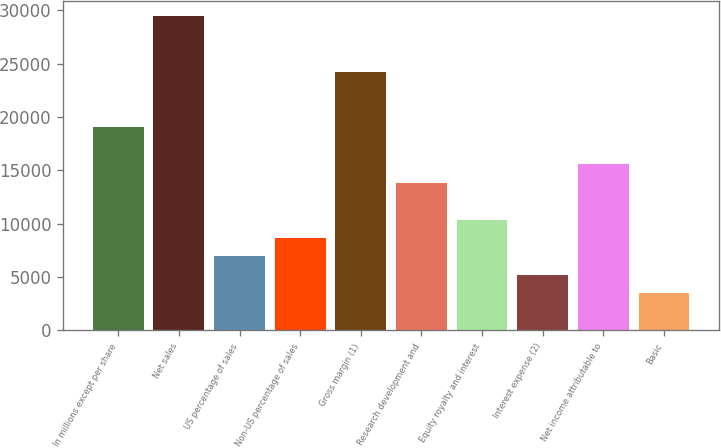Convert chart. <chart><loc_0><loc_0><loc_500><loc_500><bar_chart><fcel>In millions except per share<fcel>Net sales<fcel>US percentage of sales<fcel>Non-US percentage of sales<fcel>Gross margin (1)<fcel>Research development and<fcel>Equity royalty and interest<fcel>Interest expense (2)<fcel>Net income attributable to<fcel>Basic<nl><fcel>19030.8<fcel>29410.1<fcel>6921.73<fcel>8651.6<fcel>24220.5<fcel>13841.2<fcel>10381.5<fcel>5191.86<fcel>15571.1<fcel>3461.99<nl></chart> 